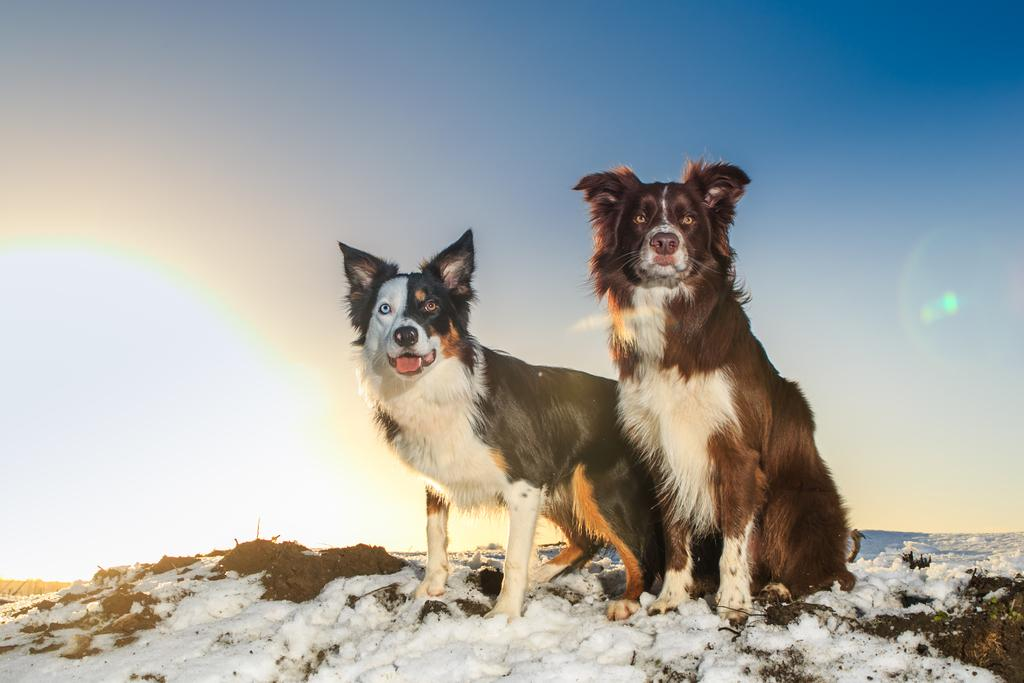How many dogs are present in the image? There are two dogs in the image. What is the condition of the ground in the image? There is snow on the ground in the image. What can be seen in the background of the image? There is sky visible in the background of the image. What type of banana can be seen hanging from the tree in the image? There is no tree or banana present in the image; it features two dogs in the snow. How are the apples being sorted in the image? There are no apples or sorting activity present in the image. 